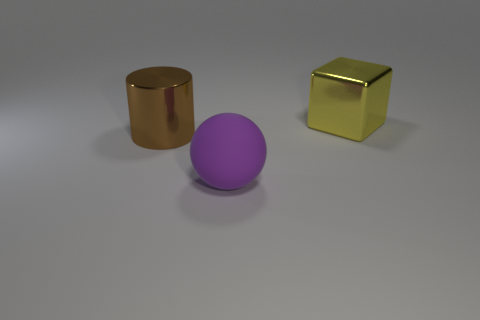Add 3 metal things. How many objects exist? 6 Subtract all spheres. How many objects are left? 2 Add 2 yellow shiny things. How many yellow shiny things are left? 3 Add 3 small green metallic blocks. How many small green metallic blocks exist? 3 Subtract 1 purple balls. How many objects are left? 2 Subtract all brown things. Subtract all purple objects. How many objects are left? 1 